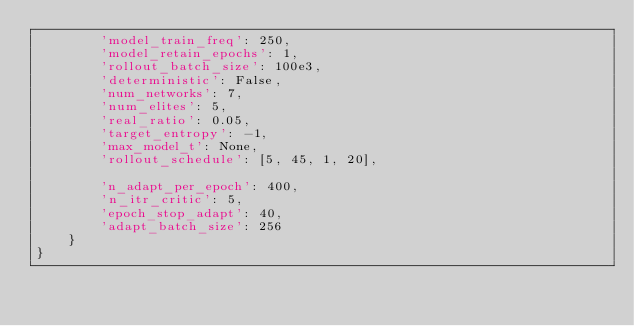Convert code to text. <code><loc_0><loc_0><loc_500><loc_500><_Python_>        'model_train_freq': 250,
        'model_retain_epochs': 1,
        'rollout_batch_size': 100e3,
        'deterministic': False,
        'num_networks': 7,
        'num_elites': 5,
        'real_ratio': 0.05,
        'target_entropy': -1,
        'max_model_t': None,
        'rollout_schedule': [5, 45, 1, 20],

        'n_adapt_per_epoch': 400,
        'n_itr_critic': 5,
        'epoch_stop_adapt': 40,
        'adapt_batch_size': 256
    }
}
</code> 